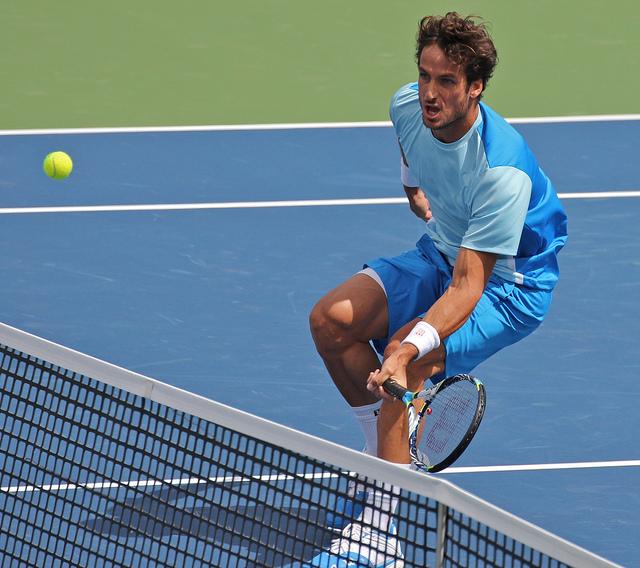Is the man's hair curly or straight?
Quick response, please. Curly. Is the man relaxing?
Answer briefly. No. What is the color of the ball?
Answer briefly. Yellow. 